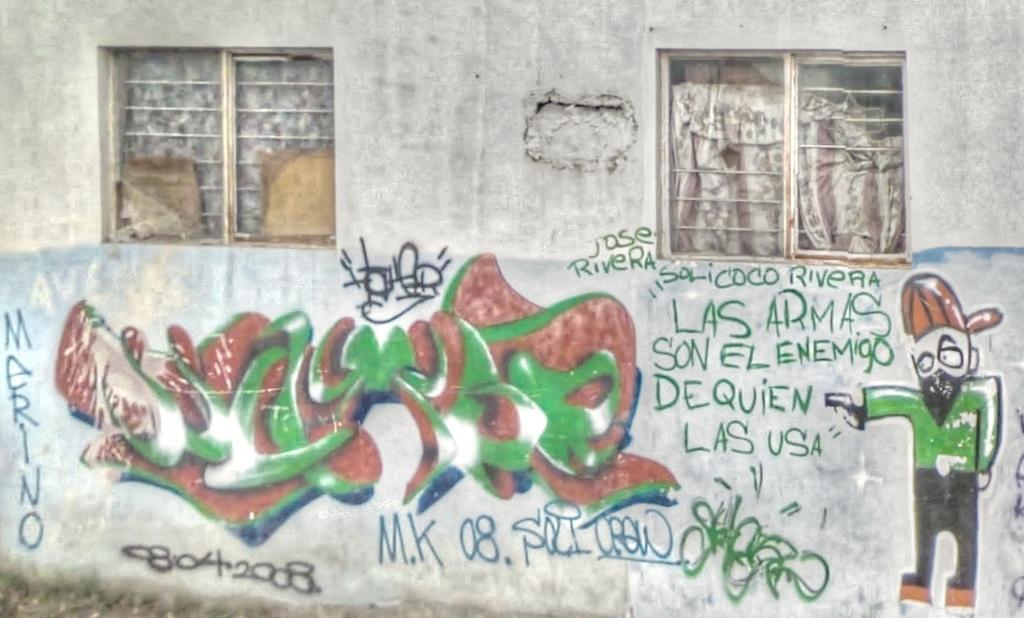What can be seen on the wall in the image? There are scribblings on the wall in the image. What is a feature of the room that allows light to enter? There are windows in the image. What type of window treatment is present in the image? There are curtains in the image. What type of bloodstain can be seen on the toothpaste in the image? There is no toothpaste or bloodstain present in the image. 